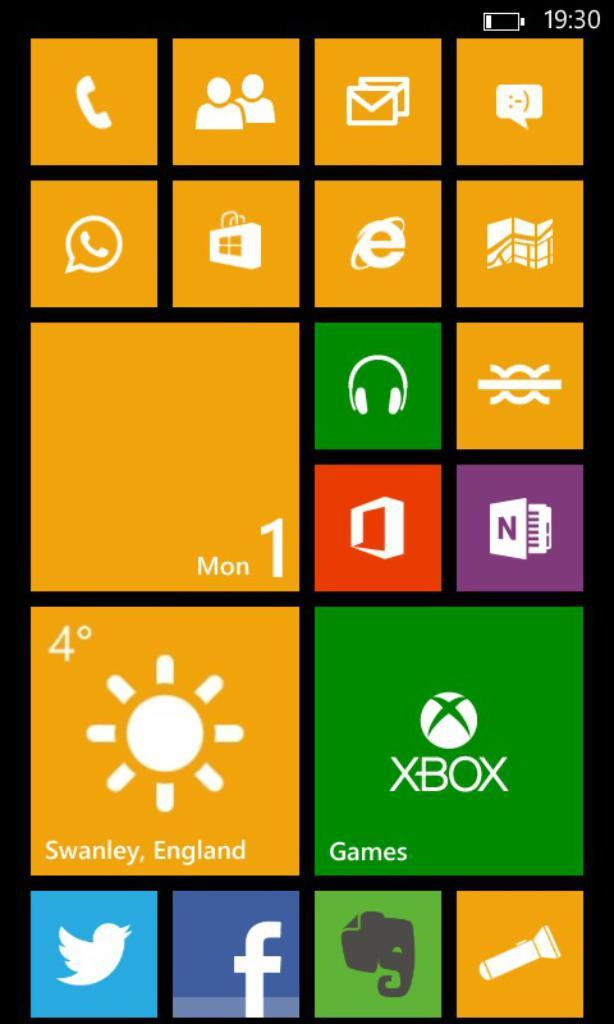What type of image is being described? The image is a screenshot of a mobile home page. What is the purpose of the home page? The home page displays the menu of all the applications in a mobile phone. How many boats are visible on the home page? There are no boats visible on the home page, as it is a screenshot of a mobile home page displaying application icons. 